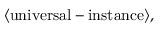Convert formula to latex. <formula><loc_0><loc_0><loc_500><loc_500>\langle u n i v e r s a l - i n s t a n c e \rangle ,</formula> 